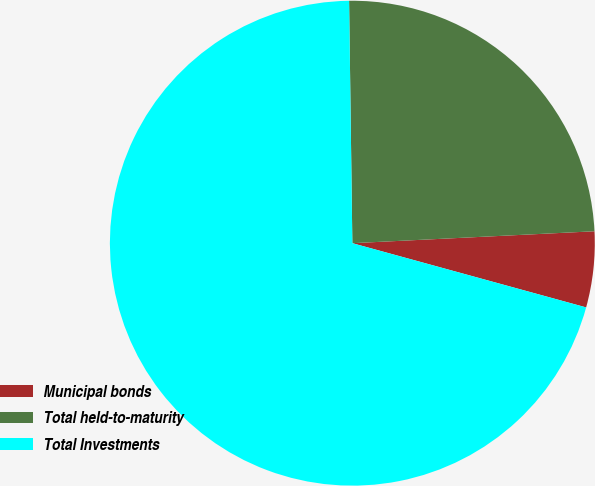<chart> <loc_0><loc_0><loc_500><loc_500><pie_chart><fcel>Municipal bonds<fcel>Total held-to-maturity<fcel>Total Investments<nl><fcel>5.05%<fcel>24.43%<fcel>70.52%<nl></chart> 